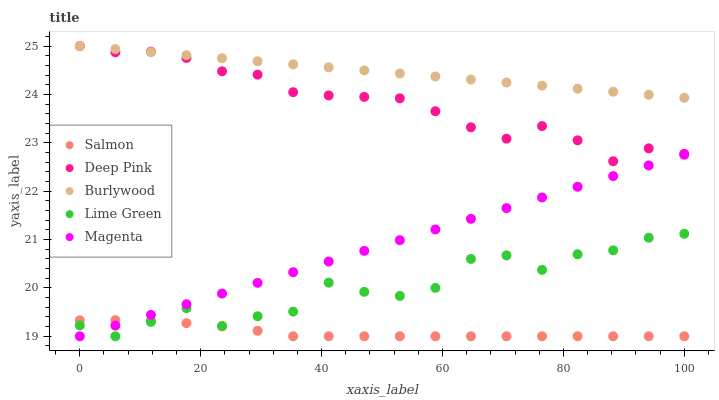Does Salmon have the minimum area under the curve?
Answer yes or no. Yes. Does Burlywood have the maximum area under the curve?
Answer yes or no. Yes. Does Lime Green have the minimum area under the curve?
Answer yes or no. No. Does Lime Green have the maximum area under the curve?
Answer yes or no. No. Is Burlywood the smoothest?
Answer yes or no. Yes. Is Lime Green the roughest?
Answer yes or no. Yes. Is Magenta the smoothest?
Answer yes or no. No. Is Magenta the roughest?
Answer yes or no. No. Does Lime Green have the lowest value?
Answer yes or no. Yes. Does Deep Pink have the lowest value?
Answer yes or no. No. Does Burlywood have the highest value?
Answer yes or no. Yes. Does Lime Green have the highest value?
Answer yes or no. No. Is Salmon less than Burlywood?
Answer yes or no. Yes. Is Burlywood greater than Magenta?
Answer yes or no. Yes. Does Magenta intersect Lime Green?
Answer yes or no. Yes. Is Magenta less than Lime Green?
Answer yes or no. No. Is Magenta greater than Lime Green?
Answer yes or no. No. Does Salmon intersect Burlywood?
Answer yes or no. No. 